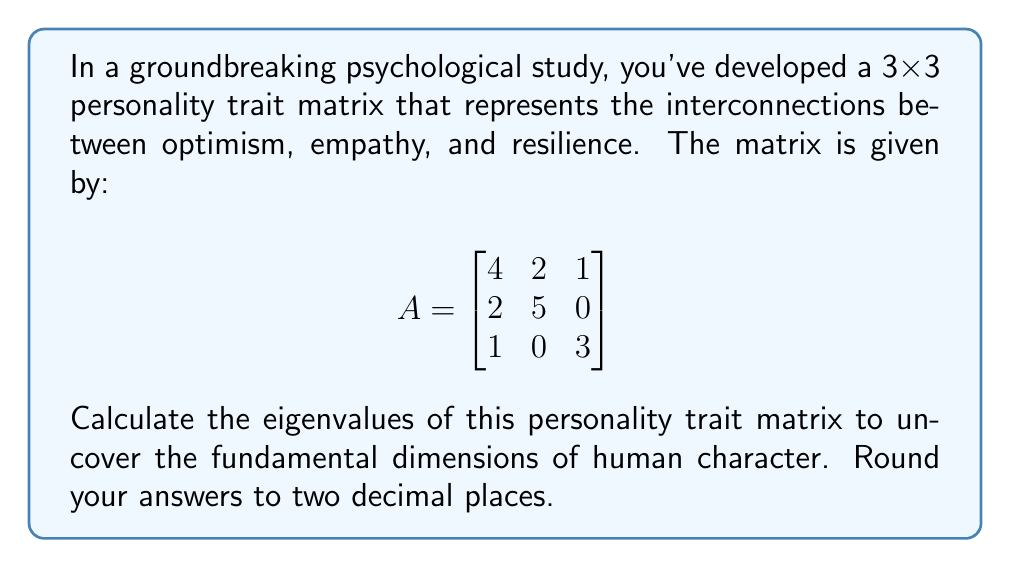Provide a solution to this math problem. To find the eigenvalues of matrix A, we need to solve the characteristic equation:

$$det(A - \lambda I) = 0$$

Where $\lambda$ represents the eigenvalues and I is the 3x3 identity matrix.

Step 1: Set up the characteristic equation
$$det\begin{pmatrix}
4-\lambda & 2 & 1 \\
2 & 5-\lambda & 0 \\
1 & 0 & 3-\lambda
\end{pmatrix} = 0$$

Step 2: Expand the determinant
$$(4-\lambda)[(5-\lambda)(3-\lambda) - 0] - 2[2(3-\lambda) - 1(0)] + 1[2(0) - 1(5-\lambda)] = 0$$

Step 3: Simplify
$$(4-\lambda)(15-8\lambda+\lambda^2) - 2(6-2\lambda) - (5-\lambda) = 0$$
$$60-32\lambda+4\lambda^2-15\lambda+8\lambda^2-\lambda^3 - 12+4\lambda - 5+\lambda = 0$$

Step 4: Collect like terms
$$-\lambda^3 + 12\lambda^2 - 43\lambda + 43 = 0$$

Step 5: Solve the cubic equation
This cubic equation can be solved using various methods such as the cubic formula or numerical methods. Using a computer algebra system or calculator, we find the roots:

$\lambda_1 \approx 6.20$
$\lambda_2 \approx 3.87$
$\lambda_3 \approx 1.93$

Rounding to two decimal places gives us our final answer.
Answer: The eigenvalues of the personality trait matrix are approximately 6.20, 3.87, and 1.93. 